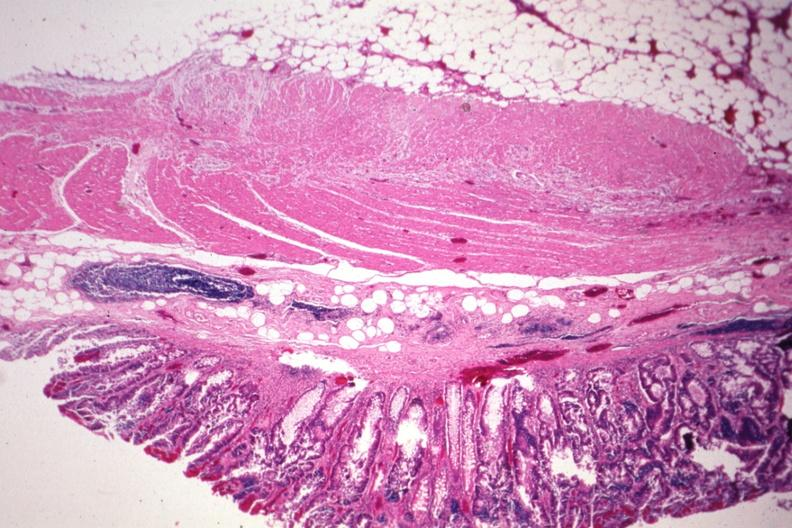how does this image show nice photo?
Answer the question using a single word or phrase. With obvious tumor in mucosa 